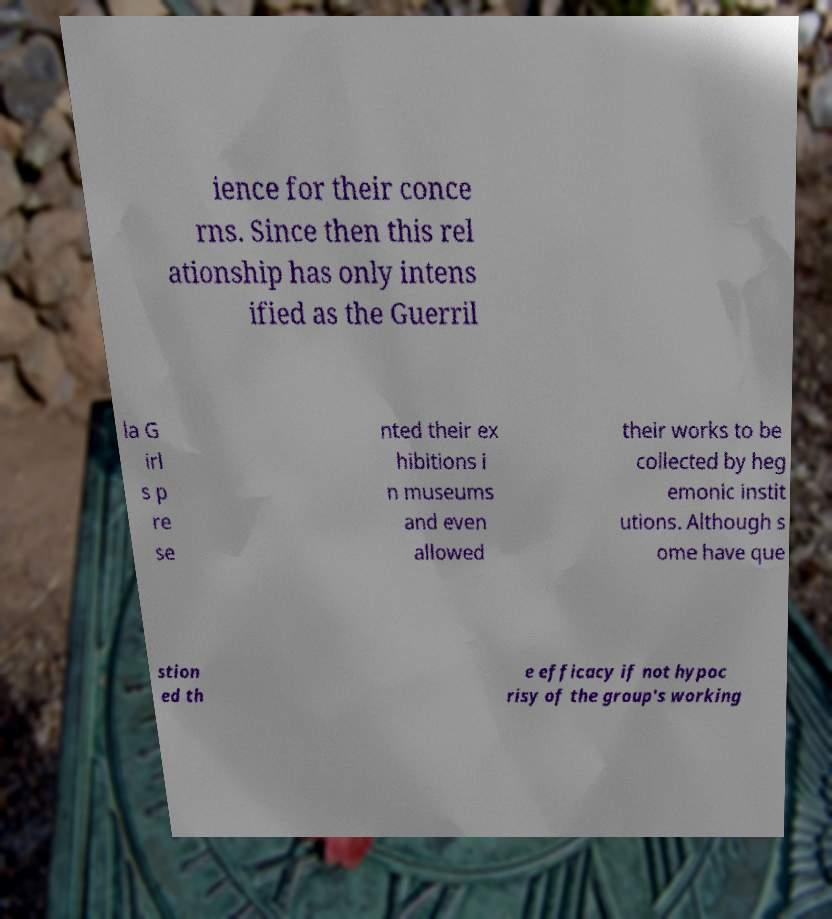Can you accurately transcribe the text from the provided image for me? ience for their conce rns. Since then this rel ationship has only intens ified as the Guerril la G irl s p re se nted their ex hibitions i n museums and even allowed their works to be collected by heg emonic instit utions. Although s ome have que stion ed th e efficacy if not hypoc risy of the group's working 